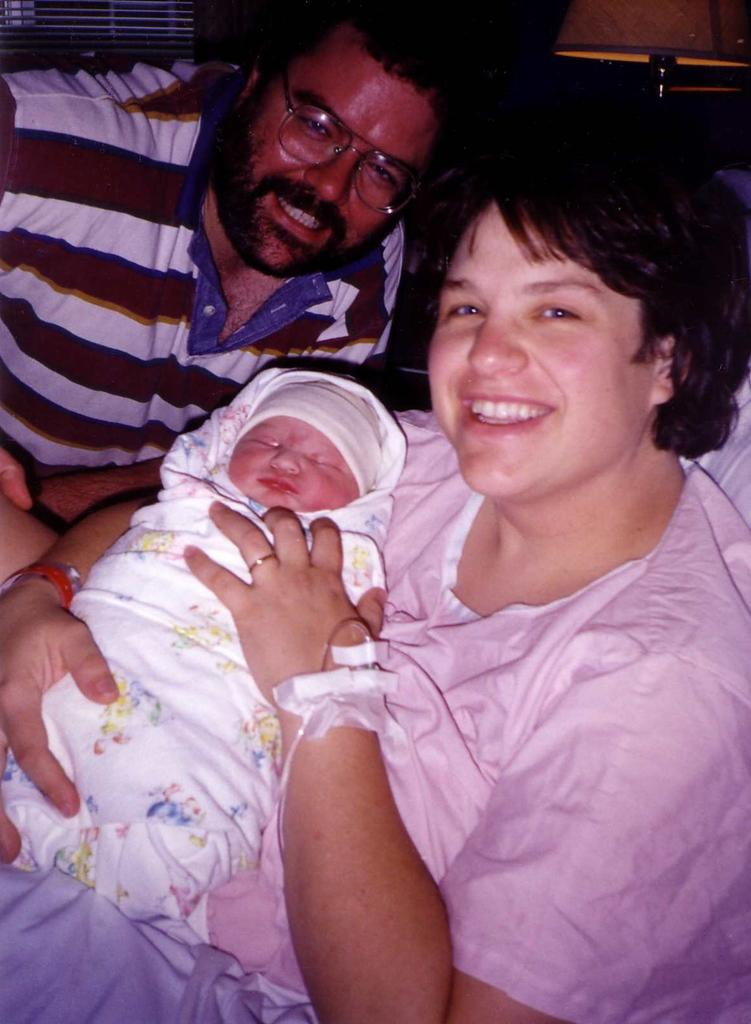Who is present in the image? There is a woman and a man in the image. What is the woman doing in the image? The woman is holding a little child. What is the woman wearing in the image? The woman is wearing a pink dress. What is the man doing in the image? The man is smiling. What is the man wearing in the image? The man is wearing a t-shirt. How many boats can be seen in the image? There are no boats present in the image. What type of kick is the man performing in the image? There is no kick being performed in the image; the man is simply smiling. 